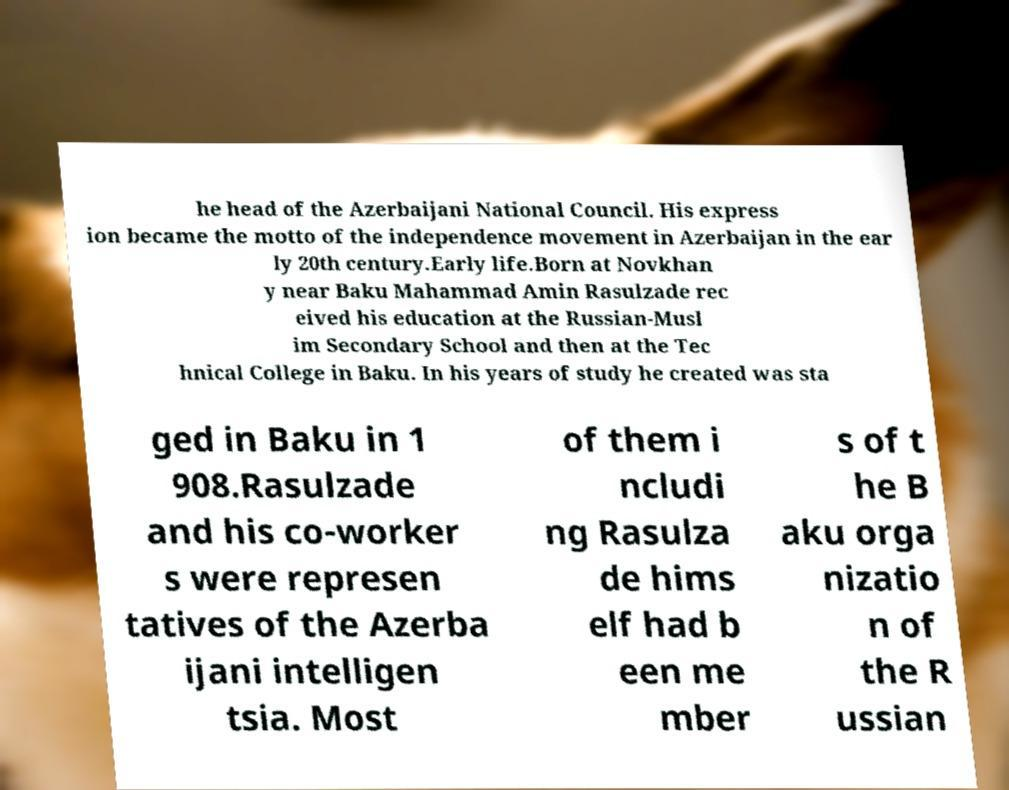Please identify and transcribe the text found in this image. he head of the Azerbaijani National Council. His express ion became the motto of the independence movement in Azerbaijan in the ear ly 20th century.Early life.Born at Novkhan y near Baku Mahammad Amin Rasulzade rec eived his education at the Russian-Musl im Secondary School and then at the Tec hnical College in Baku. In his years of study he created was sta ged in Baku in 1 908.Rasulzade and his co-worker s were represen tatives of the Azerba ijani intelligen tsia. Most of them i ncludi ng Rasulza de hims elf had b een me mber s of t he B aku orga nizatio n of the R ussian 